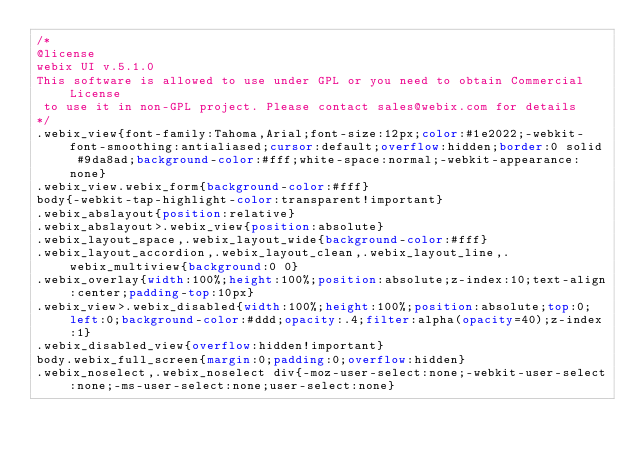Convert code to text. <code><loc_0><loc_0><loc_500><loc_500><_CSS_>/*
@license
webix UI v.5.1.0
This software is allowed to use under GPL or you need to obtain Commercial License 
 to use it in non-GPL project. Please contact sales@webix.com for details
*/
.webix_view{font-family:Tahoma,Arial;font-size:12px;color:#1e2022;-webkit-font-smoothing:antialiased;cursor:default;overflow:hidden;border:0 solid #9da8ad;background-color:#fff;white-space:normal;-webkit-appearance:none}
.webix_view.webix_form{background-color:#fff}
body{-webkit-tap-highlight-color:transparent!important}
.webix_abslayout{position:relative}
.webix_abslayout>.webix_view{position:absolute}
.webix_layout_space,.webix_layout_wide{background-color:#fff}
.webix_layout_accordion,.webix_layout_clean,.webix_layout_line,.webix_multiview{background:0 0}
.webix_overlay{width:100%;height:100%;position:absolute;z-index:10;text-align:center;padding-top:10px}
.webix_view>.webix_disabled{width:100%;height:100%;position:absolute;top:0;left:0;background-color:#ddd;opacity:.4;filter:alpha(opacity=40);z-index:1}
.webix_disabled_view{overflow:hidden!important}
body.webix_full_screen{margin:0;padding:0;overflow:hidden}
.webix_noselect,.webix_noselect div{-moz-user-select:none;-webkit-user-select:none;-ms-user-select:none;user-select:none}</code> 